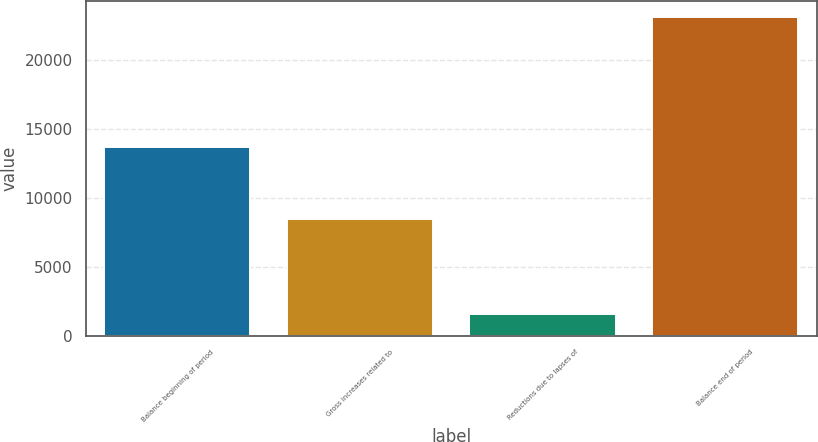Convert chart to OTSL. <chart><loc_0><loc_0><loc_500><loc_500><bar_chart><fcel>Balance beginning of period<fcel>Gross increases related to<fcel>Reductions due to lapses of<fcel>Balance end of period<nl><fcel>13687<fcel>8507<fcel>1588<fcel>23135<nl></chart> 